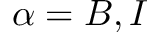Convert formula to latex. <formula><loc_0><loc_0><loc_500><loc_500>\alpha = B , I</formula> 